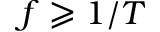Convert formula to latex. <formula><loc_0><loc_0><loc_500><loc_500>f \geqslant 1 / T</formula> 